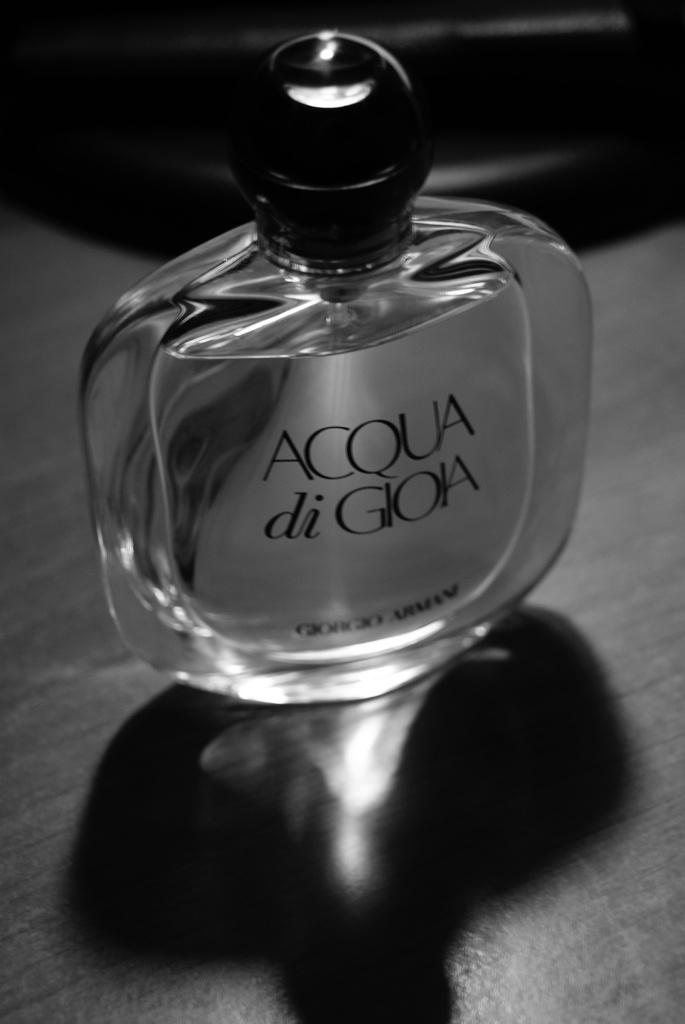<image>
Summarize the visual content of the image. a small clear bottle of 'acqua di giola' 